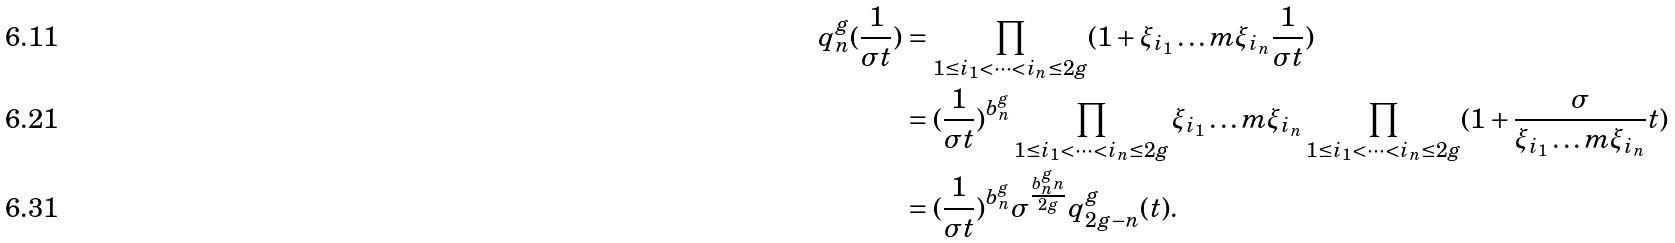Convert formula to latex. <formula><loc_0><loc_0><loc_500><loc_500>q ^ { g } _ { n } ( \frac { 1 } { \sigma t } ) & = \prod _ { 1 \leq i _ { 1 } < \dots < i _ { n } \leq 2 g } ( 1 + \xi _ { i _ { 1 } } \dots m \xi _ { i _ { n } } \frac { 1 } { \sigma t } ) \\ & = ( \frac { 1 } { \sigma t } ) ^ { b ^ { g } _ { n } } \prod _ { 1 \leq i _ { 1 } < \dots < i _ { n } \leq 2 g } \xi _ { i _ { 1 } } \dots m \xi _ { i _ { n } } \prod _ { 1 \leq i _ { 1 } < \dots < i _ { n } \leq 2 g } ( 1 + \frac { \sigma } { \xi _ { i _ { 1 } } \dots m \xi _ { i _ { n } } } t ) \\ & = ( \frac { 1 } { \sigma t } ) ^ { b ^ { g } _ { n } } { \sigma } ^ { \frac { b ^ { g } _ { n } n } { 2 g } } q ^ { g } _ { 2 g - n } ( t ) .</formula> 